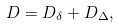<formula> <loc_0><loc_0><loc_500><loc_500>D = D _ { \delta } + D _ { \Delta } ,</formula> 